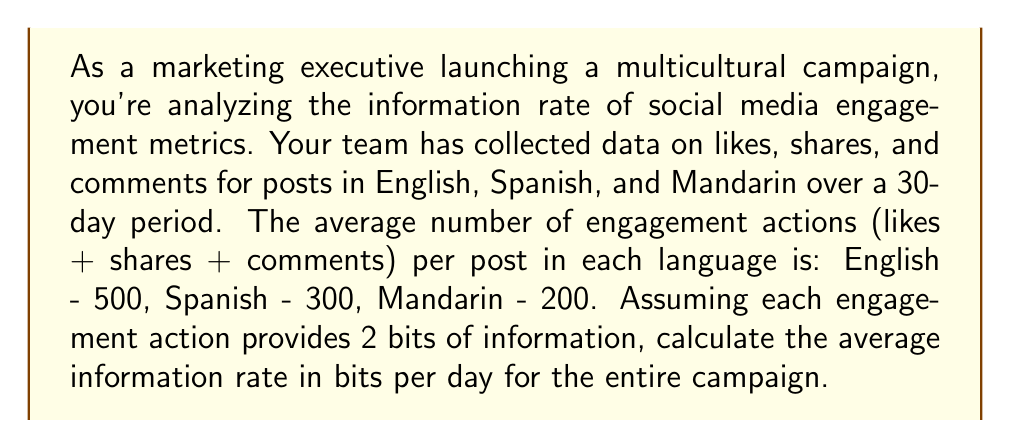What is the answer to this math problem? To solve this problem, we'll use concepts from information theory and follow these steps:

1. Calculate the total number of engagement actions per day:
   $$(500 + 300 + 200) = 1000$$ actions per day

2. Convert engagement actions to bits of information:
   Each action provides 2 bits, so:
   $$1000 \times 2 = 2000$$ bits per day

3. Calculate the information rate:
   The information rate is the amount of information transmitted per unit time. In this case, it's bits per day, which we've already calculated.

4. Express the result:
   The average information rate is 2000 bits per day.

Note: In information theory, the actual calculation of bits would typically involve logarithms based on the probability of each event. However, for the purposes of this marketing-oriented question, we've simplified by assigning a fixed number of bits to each engagement action.
Answer: The average information rate for the multicultural social media campaign is 2000 bits per day. 